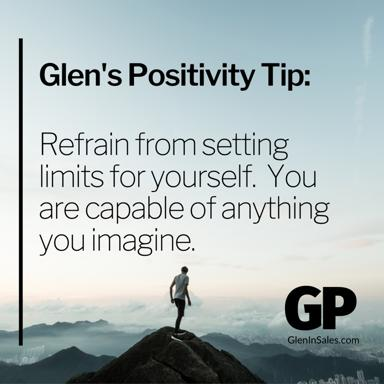What is Glen's Positivity Tip?
 Glen's Positivity Tip is to refrain from setting limits for yourself, as you are capable of anything you imagine. What message does the image of a man standing on top of a mountain convey in relation to Glen's Positivity Tip? The image of a man standing on top of a mountain signifies achievement, determination, and overcoming challenges. It conveys the idea that by not setting limits for ourselves and believing in our capabilities, we can reach great heights and accomplish extraordinary things, just as the man has reached the summit of the mountain. This visual representation emphasizes the power of a positive mindset and self-belief. 